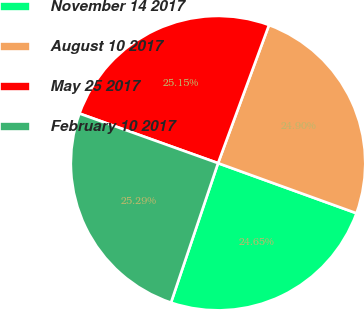<chart> <loc_0><loc_0><loc_500><loc_500><pie_chart><fcel>November 14 2017<fcel>August 10 2017<fcel>May 25 2017<fcel>February 10 2017<nl><fcel>24.65%<fcel>24.9%<fcel>25.15%<fcel>25.29%<nl></chart> 